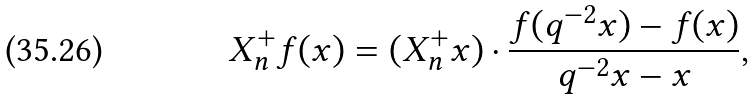<formula> <loc_0><loc_0><loc_500><loc_500>X _ { n } ^ { + } f ( x ) = ( X _ { n } ^ { + } x ) \cdot \frac { f ( q ^ { - 2 } x ) - f ( x ) } { q ^ { - 2 } x - x } ,</formula> 